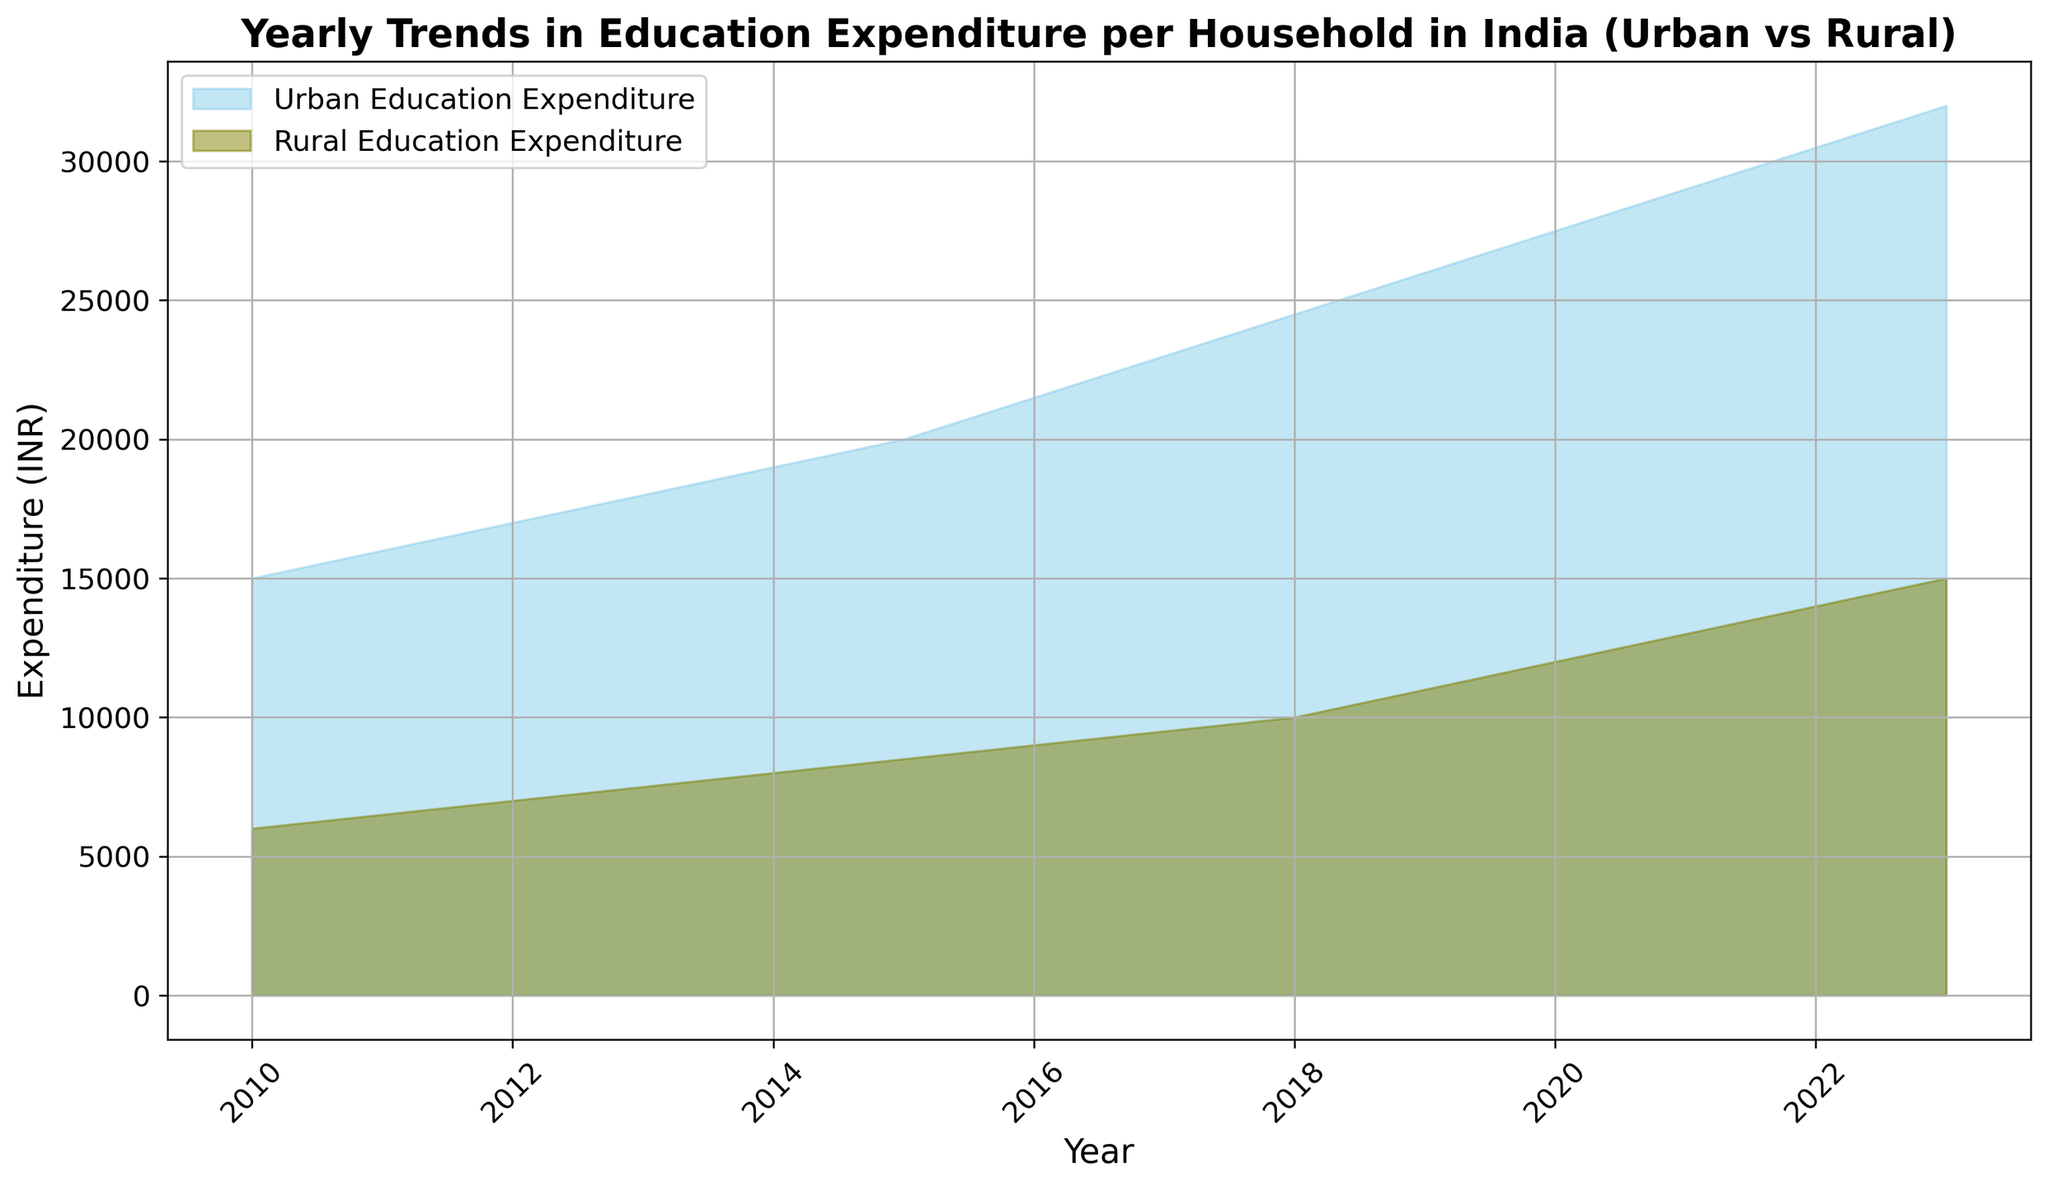What is the difference in education expenditure between urban and rural households in 2023? To find the difference, refer to the year 2023 on both the urban and rural lines. Subtract the expenditure of rural households (15,000 INR) from that of urban households (32,000 INR). 32,000 - 15,000 = 17,000.
Answer: 17,000 INR How has the education expenditure trend for rural households changed from 2010 to 2023? Look at the expenditure values for rural households in 2010 (6,000 INR) and 2023 (15,000 INR). There is a noticeable increase, indicating a rising trend.
Answer: Increasing Which year saw urban education expenditure surpass 25,000 INR for the first time? Check the urban expenditure data to find the first year where the value exceeds 25,000 INR. In 2019, the value is 26,000 INR.
Answer: 2019 By how much did urban education expenditure increase from 2010 to 2020? Subtract the urban expenditure in 2010 (15,000 INR) from that in 2020 (27,500 INR). 27,500 - 15,000 = 12,500.
Answer: 12,500 INR In which year is the gap between urban and rural education expenditure the smallest? Compare the differences between urban and rural expenditures for each year. The smallest gap occurs in 2010, where the difference is 15,000 - 6,000 = 9,000 INR.
Answer: 2010 What's the average annual increase in rural education expenditure over the entire period? Calculate the total increase from 2010 to 2023 (15,000 - 6,000 = 9,000). Then, divide 9,000 by the number of years (2023 - 2010 = 13 years). 9,000 / 13 ≈ 692.3 INR/year.
Answer: ~692.3 INR/year In what year did both urban and rural education expenditures see the same annual increase of 1,500 INR compared to the previous year? Look for consecutive years where both expenditures increased by 1,500 INR. From 2021 to 2022, urban (29,000 to 30,500) and rural (13,000 to 14,000) both increased by 1,500 INR.
Answer: 2022 How many times did the rural education expenditure increase by at least 1,000 INR from one year to the next? Count the number of years where rural expenditure increased by 1,000 INR or more: 2014 to 2015 (500), 2015 to 2016 (500), and so on. There are 5 instances: 2015-2016, 2016-2017, 2017-2018, 2019-2020, and 2020-2021.
Answer: 5 times 